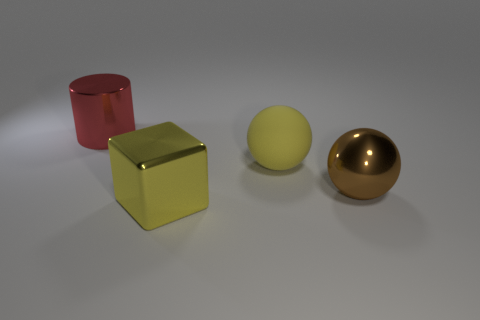Add 4 red blocks. How many objects exist? 8 Subtract all cylinders. How many objects are left? 3 Add 1 small shiny objects. How many small shiny objects exist? 1 Subtract 0 green cylinders. How many objects are left? 4 Subtract all brown metallic cylinders. Subtract all large objects. How many objects are left? 0 Add 1 large yellow objects. How many large yellow objects are left? 3 